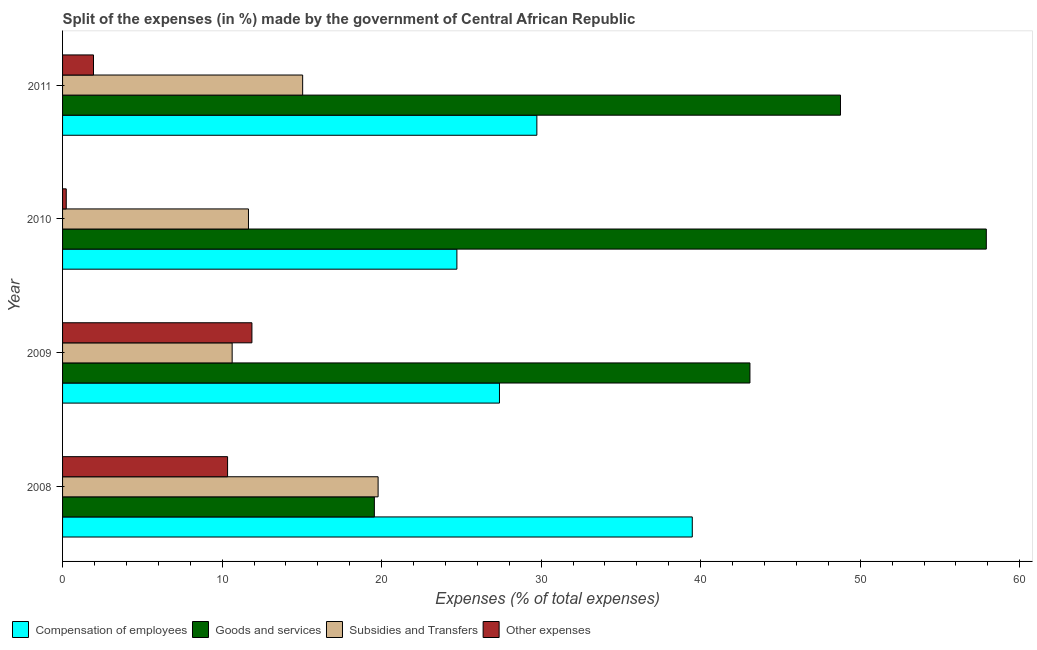How many different coloured bars are there?
Keep it short and to the point. 4. Are the number of bars per tick equal to the number of legend labels?
Your answer should be compact. Yes. How many bars are there on the 3rd tick from the bottom?
Your answer should be compact. 4. What is the label of the 4th group of bars from the top?
Provide a short and direct response. 2008. What is the percentage of amount spent on compensation of employees in 2009?
Provide a short and direct response. 27.39. Across all years, what is the maximum percentage of amount spent on other expenses?
Your answer should be very brief. 11.87. Across all years, what is the minimum percentage of amount spent on subsidies?
Offer a very short reply. 10.63. In which year was the percentage of amount spent on goods and services maximum?
Give a very brief answer. 2010. In which year was the percentage of amount spent on goods and services minimum?
Offer a very short reply. 2008. What is the total percentage of amount spent on goods and services in the graph?
Your answer should be compact. 169.3. What is the difference between the percentage of amount spent on compensation of employees in 2010 and that in 2011?
Offer a terse response. -5.01. What is the difference between the percentage of amount spent on subsidies in 2010 and the percentage of amount spent on compensation of employees in 2009?
Offer a terse response. -15.73. What is the average percentage of amount spent on subsidies per year?
Offer a very short reply. 14.28. In the year 2011, what is the difference between the percentage of amount spent on compensation of employees and percentage of amount spent on goods and services?
Ensure brevity in your answer.  -19.03. In how many years, is the percentage of amount spent on subsidies greater than 16 %?
Your answer should be compact. 1. What is the ratio of the percentage of amount spent on goods and services in 2008 to that in 2009?
Offer a terse response. 0.45. What is the difference between the highest and the second highest percentage of amount spent on other expenses?
Offer a very short reply. 1.53. What is the difference between the highest and the lowest percentage of amount spent on subsidies?
Keep it short and to the point. 9.15. Is it the case that in every year, the sum of the percentage of amount spent on goods and services and percentage of amount spent on other expenses is greater than the sum of percentage of amount spent on compensation of employees and percentage of amount spent on subsidies?
Provide a short and direct response. No. What does the 1st bar from the top in 2008 represents?
Ensure brevity in your answer.  Other expenses. What does the 1st bar from the bottom in 2008 represents?
Offer a very short reply. Compensation of employees. How many bars are there?
Your answer should be very brief. 16. Are all the bars in the graph horizontal?
Offer a terse response. Yes. How many years are there in the graph?
Your response must be concise. 4. What is the difference between two consecutive major ticks on the X-axis?
Offer a very short reply. 10. What is the title of the graph?
Offer a very short reply. Split of the expenses (in %) made by the government of Central African Republic. Does "Social Protection" appear as one of the legend labels in the graph?
Your response must be concise. No. What is the label or title of the X-axis?
Your response must be concise. Expenses (% of total expenses). What is the Expenses (% of total expenses) in Compensation of employees in 2008?
Your answer should be compact. 39.47. What is the Expenses (% of total expenses) of Goods and services in 2008?
Offer a very short reply. 19.55. What is the Expenses (% of total expenses) in Subsidies and Transfers in 2008?
Provide a short and direct response. 19.78. What is the Expenses (% of total expenses) of Other expenses in 2008?
Ensure brevity in your answer.  10.34. What is the Expenses (% of total expenses) in Compensation of employees in 2009?
Give a very brief answer. 27.39. What is the Expenses (% of total expenses) in Goods and services in 2009?
Your answer should be very brief. 43.09. What is the Expenses (% of total expenses) of Subsidies and Transfers in 2009?
Make the answer very short. 10.63. What is the Expenses (% of total expenses) in Other expenses in 2009?
Ensure brevity in your answer.  11.87. What is the Expenses (% of total expenses) in Compensation of employees in 2010?
Keep it short and to the point. 24.72. What is the Expenses (% of total expenses) in Goods and services in 2010?
Ensure brevity in your answer.  57.91. What is the Expenses (% of total expenses) in Subsidies and Transfers in 2010?
Make the answer very short. 11.65. What is the Expenses (% of total expenses) in Other expenses in 2010?
Keep it short and to the point. 0.23. What is the Expenses (% of total expenses) in Compensation of employees in 2011?
Your response must be concise. 29.73. What is the Expenses (% of total expenses) in Goods and services in 2011?
Your answer should be very brief. 48.76. What is the Expenses (% of total expenses) of Subsidies and Transfers in 2011?
Your response must be concise. 15.05. What is the Expenses (% of total expenses) of Other expenses in 2011?
Keep it short and to the point. 1.94. Across all years, what is the maximum Expenses (% of total expenses) in Compensation of employees?
Your answer should be very brief. 39.47. Across all years, what is the maximum Expenses (% of total expenses) of Goods and services?
Your answer should be very brief. 57.91. Across all years, what is the maximum Expenses (% of total expenses) in Subsidies and Transfers?
Provide a short and direct response. 19.78. Across all years, what is the maximum Expenses (% of total expenses) of Other expenses?
Provide a short and direct response. 11.87. Across all years, what is the minimum Expenses (% of total expenses) of Compensation of employees?
Provide a succinct answer. 24.72. Across all years, what is the minimum Expenses (% of total expenses) in Goods and services?
Keep it short and to the point. 19.55. Across all years, what is the minimum Expenses (% of total expenses) in Subsidies and Transfers?
Offer a very short reply. 10.63. Across all years, what is the minimum Expenses (% of total expenses) of Other expenses?
Ensure brevity in your answer.  0.23. What is the total Expenses (% of total expenses) in Compensation of employees in the graph?
Keep it short and to the point. 121.31. What is the total Expenses (% of total expenses) of Goods and services in the graph?
Provide a succinct answer. 169.3. What is the total Expenses (% of total expenses) in Subsidies and Transfers in the graph?
Keep it short and to the point. 57.11. What is the total Expenses (% of total expenses) of Other expenses in the graph?
Your response must be concise. 24.38. What is the difference between the Expenses (% of total expenses) in Compensation of employees in 2008 and that in 2009?
Make the answer very short. 12.09. What is the difference between the Expenses (% of total expenses) in Goods and services in 2008 and that in 2009?
Your answer should be very brief. -23.54. What is the difference between the Expenses (% of total expenses) in Subsidies and Transfers in 2008 and that in 2009?
Your answer should be compact. 9.15. What is the difference between the Expenses (% of total expenses) in Other expenses in 2008 and that in 2009?
Your response must be concise. -1.53. What is the difference between the Expenses (% of total expenses) of Compensation of employees in 2008 and that in 2010?
Offer a terse response. 14.76. What is the difference between the Expenses (% of total expenses) of Goods and services in 2008 and that in 2010?
Ensure brevity in your answer.  -38.36. What is the difference between the Expenses (% of total expenses) in Subsidies and Transfers in 2008 and that in 2010?
Offer a very short reply. 8.13. What is the difference between the Expenses (% of total expenses) of Other expenses in 2008 and that in 2010?
Provide a short and direct response. 10.11. What is the difference between the Expenses (% of total expenses) in Compensation of employees in 2008 and that in 2011?
Keep it short and to the point. 9.74. What is the difference between the Expenses (% of total expenses) of Goods and services in 2008 and that in 2011?
Your response must be concise. -29.22. What is the difference between the Expenses (% of total expenses) of Subsidies and Transfers in 2008 and that in 2011?
Keep it short and to the point. 4.73. What is the difference between the Expenses (% of total expenses) of Other expenses in 2008 and that in 2011?
Give a very brief answer. 8.4. What is the difference between the Expenses (% of total expenses) of Compensation of employees in 2009 and that in 2010?
Make the answer very short. 2.67. What is the difference between the Expenses (% of total expenses) in Goods and services in 2009 and that in 2010?
Provide a succinct answer. -14.82. What is the difference between the Expenses (% of total expenses) of Subsidies and Transfers in 2009 and that in 2010?
Make the answer very short. -1.02. What is the difference between the Expenses (% of total expenses) in Other expenses in 2009 and that in 2010?
Provide a succinct answer. 11.64. What is the difference between the Expenses (% of total expenses) of Compensation of employees in 2009 and that in 2011?
Your answer should be very brief. -2.34. What is the difference between the Expenses (% of total expenses) of Goods and services in 2009 and that in 2011?
Provide a succinct answer. -5.68. What is the difference between the Expenses (% of total expenses) of Subsidies and Transfers in 2009 and that in 2011?
Make the answer very short. -4.42. What is the difference between the Expenses (% of total expenses) in Other expenses in 2009 and that in 2011?
Your response must be concise. 9.93. What is the difference between the Expenses (% of total expenses) of Compensation of employees in 2010 and that in 2011?
Your answer should be very brief. -5.01. What is the difference between the Expenses (% of total expenses) of Goods and services in 2010 and that in 2011?
Provide a short and direct response. 9.14. What is the difference between the Expenses (% of total expenses) of Subsidies and Transfers in 2010 and that in 2011?
Offer a terse response. -3.4. What is the difference between the Expenses (% of total expenses) of Other expenses in 2010 and that in 2011?
Make the answer very short. -1.71. What is the difference between the Expenses (% of total expenses) in Compensation of employees in 2008 and the Expenses (% of total expenses) in Goods and services in 2009?
Give a very brief answer. -3.61. What is the difference between the Expenses (% of total expenses) of Compensation of employees in 2008 and the Expenses (% of total expenses) of Subsidies and Transfers in 2009?
Your answer should be very brief. 28.84. What is the difference between the Expenses (% of total expenses) in Compensation of employees in 2008 and the Expenses (% of total expenses) in Other expenses in 2009?
Provide a succinct answer. 27.6. What is the difference between the Expenses (% of total expenses) of Goods and services in 2008 and the Expenses (% of total expenses) of Subsidies and Transfers in 2009?
Give a very brief answer. 8.91. What is the difference between the Expenses (% of total expenses) in Goods and services in 2008 and the Expenses (% of total expenses) in Other expenses in 2009?
Provide a short and direct response. 7.68. What is the difference between the Expenses (% of total expenses) in Subsidies and Transfers in 2008 and the Expenses (% of total expenses) in Other expenses in 2009?
Provide a short and direct response. 7.91. What is the difference between the Expenses (% of total expenses) in Compensation of employees in 2008 and the Expenses (% of total expenses) in Goods and services in 2010?
Provide a short and direct response. -18.43. What is the difference between the Expenses (% of total expenses) in Compensation of employees in 2008 and the Expenses (% of total expenses) in Subsidies and Transfers in 2010?
Give a very brief answer. 27.82. What is the difference between the Expenses (% of total expenses) in Compensation of employees in 2008 and the Expenses (% of total expenses) in Other expenses in 2010?
Your answer should be very brief. 39.24. What is the difference between the Expenses (% of total expenses) in Goods and services in 2008 and the Expenses (% of total expenses) in Subsidies and Transfers in 2010?
Your answer should be very brief. 7.89. What is the difference between the Expenses (% of total expenses) of Goods and services in 2008 and the Expenses (% of total expenses) of Other expenses in 2010?
Give a very brief answer. 19.31. What is the difference between the Expenses (% of total expenses) of Subsidies and Transfers in 2008 and the Expenses (% of total expenses) of Other expenses in 2010?
Provide a succinct answer. 19.55. What is the difference between the Expenses (% of total expenses) in Compensation of employees in 2008 and the Expenses (% of total expenses) in Goods and services in 2011?
Give a very brief answer. -9.29. What is the difference between the Expenses (% of total expenses) in Compensation of employees in 2008 and the Expenses (% of total expenses) in Subsidies and Transfers in 2011?
Make the answer very short. 24.42. What is the difference between the Expenses (% of total expenses) in Compensation of employees in 2008 and the Expenses (% of total expenses) in Other expenses in 2011?
Your answer should be compact. 37.53. What is the difference between the Expenses (% of total expenses) of Goods and services in 2008 and the Expenses (% of total expenses) of Subsidies and Transfers in 2011?
Give a very brief answer. 4.5. What is the difference between the Expenses (% of total expenses) in Goods and services in 2008 and the Expenses (% of total expenses) in Other expenses in 2011?
Your response must be concise. 17.61. What is the difference between the Expenses (% of total expenses) in Subsidies and Transfers in 2008 and the Expenses (% of total expenses) in Other expenses in 2011?
Provide a short and direct response. 17.84. What is the difference between the Expenses (% of total expenses) in Compensation of employees in 2009 and the Expenses (% of total expenses) in Goods and services in 2010?
Give a very brief answer. -30.52. What is the difference between the Expenses (% of total expenses) of Compensation of employees in 2009 and the Expenses (% of total expenses) of Subsidies and Transfers in 2010?
Offer a terse response. 15.73. What is the difference between the Expenses (% of total expenses) of Compensation of employees in 2009 and the Expenses (% of total expenses) of Other expenses in 2010?
Provide a succinct answer. 27.16. What is the difference between the Expenses (% of total expenses) of Goods and services in 2009 and the Expenses (% of total expenses) of Subsidies and Transfers in 2010?
Keep it short and to the point. 31.44. What is the difference between the Expenses (% of total expenses) in Goods and services in 2009 and the Expenses (% of total expenses) in Other expenses in 2010?
Your response must be concise. 42.86. What is the difference between the Expenses (% of total expenses) of Subsidies and Transfers in 2009 and the Expenses (% of total expenses) of Other expenses in 2010?
Offer a very short reply. 10.4. What is the difference between the Expenses (% of total expenses) of Compensation of employees in 2009 and the Expenses (% of total expenses) of Goods and services in 2011?
Keep it short and to the point. -21.38. What is the difference between the Expenses (% of total expenses) of Compensation of employees in 2009 and the Expenses (% of total expenses) of Subsidies and Transfers in 2011?
Give a very brief answer. 12.34. What is the difference between the Expenses (% of total expenses) of Compensation of employees in 2009 and the Expenses (% of total expenses) of Other expenses in 2011?
Your response must be concise. 25.45. What is the difference between the Expenses (% of total expenses) in Goods and services in 2009 and the Expenses (% of total expenses) in Subsidies and Transfers in 2011?
Ensure brevity in your answer.  28.04. What is the difference between the Expenses (% of total expenses) in Goods and services in 2009 and the Expenses (% of total expenses) in Other expenses in 2011?
Your response must be concise. 41.15. What is the difference between the Expenses (% of total expenses) of Subsidies and Transfers in 2009 and the Expenses (% of total expenses) of Other expenses in 2011?
Make the answer very short. 8.69. What is the difference between the Expenses (% of total expenses) of Compensation of employees in 2010 and the Expenses (% of total expenses) of Goods and services in 2011?
Ensure brevity in your answer.  -24.05. What is the difference between the Expenses (% of total expenses) of Compensation of employees in 2010 and the Expenses (% of total expenses) of Subsidies and Transfers in 2011?
Keep it short and to the point. 9.67. What is the difference between the Expenses (% of total expenses) in Compensation of employees in 2010 and the Expenses (% of total expenses) in Other expenses in 2011?
Make the answer very short. 22.78. What is the difference between the Expenses (% of total expenses) in Goods and services in 2010 and the Expenses (% of total expenses) in Subsidies and Transfers in 2011?
Offer a terse response. 42.85. What is the difference between the Expenses (% of total expenses) of Goods and services in 2010 and the Expenses (% of total expenses) of Other expenses in 2011?
Your answer should be compact. 55.97. What is the difference between the Expenses (% of total expenses) of Subsidies and Transfers in 2010 and the Expenses (% of total expenses) of Other expenses in 2011?
Offer a terse response. 9.71. What is the average Expenses (% of total expenses) in Compensation of employees per year?
Offer a terse response. 30.33. What is the average Expenses (% of total expenses) of Goods and services per year?
Keep it short and to the point. 42.33. What is the average Expenses (% of total expenses) of Subsidies and Transfers per year?
Your answer should be compact. 14.28. What is the average Expenses (% of total expenses) of Other expenses per year?
Provide a short and direct response. 6.1. In the year 2008, what is the difference between the Expenses (% of total expenses) of Compensation of employees and Expenses (% of total expenses) of Goods and services?
Offer a very short reply. 19.93. In the year 2008, what is the difference between the Expenses (% of total expenses) in Compensation of employees and Expenses (% of total expenses) in Subsidies and Transfers?
Offer a very short reply. 19.69. In the year 2008, what is the difference between the Expenses (% of total expenses) of Compensation of employees and Expenses (% of total expenses) of Other expenses?
Give a very brief answer. 29.13. In the year 2008, what is the difference between the Expenses (% of total expenses) in Goods and services and Expenses (% of total expenses) in Subsidies and Transfers?
Offer a very short reply. -0.23. In the year 2008, what is the difference between the Expenses (% of total expenses) in Goods and services and Expenses (% of total expenses) in Other expenses?
Provide a short and direct response. 9.2. In the year 2008, what is the difference between the Expenses (% of total expenses) in Subsidies and Transfers and Expenses (% of total expenses) in Other expenses?
Your response must be concise. 9.44. In the year 2009, what is the difference between the Expenses (% of total expenses) of Compensation of employees and Expenses (% of total expenses) of Goods and services?
Make the answer very short. -15.7. In the year 2009, what is the difference between the Expenses (% of total expenses) in Compensation of employees and Expenses (% of total expenses) in Subsidies and Transfers?
Your answer should be very brief. 16.76. In the year 2009, what is the difference between the Expenses (% of total expenses) of Compensation of employees and Expenses (% of total expenses) of Other expenses?
Ensure brevity in your answer.  15.52. In the year 2009, what is the difference between the Expenses (% of total expenses) in Goods and services and Expenses (% of total expenses) in Subsidies and Transfers?
Offer a terse response. 32.46. In the year 2009, what is the difference between the Expenses (% of total expenses) in Goods and services and Expenses (% of total expenses) in Other expenses?
Offer a very short reply. 31.22. In the year 2009, what is the difference between the Expenses (% of total expenses) in Subsidies and Transfers and Expenses (% of total expenses) in Other expenses?
Make the answer very short. -1.24. In the year 2010, what is the difference between the Expenses (% of total expenses) in Compensation of employees and Expenses (% of total expenses) in Goods and services?
Your response must be concise. -33.19. In the year 2010, what is the difference between the Expenses (% of total expenses) of Compensation of employees and Expenses (% of total expenses) of Subsidies and Transfers?
Provide a succinct answer. 13.07. In the year 2010, what is the difference between the Expenses (% of total expenses) in Compensation of employees and Expenses (% of total expenses) in Other expenses?
Your response must be concise. 24.49. In the year 2010, what is the difference between the Expenses (% of total expenses) of Goods and services and Expenses (% of total expenses) of Subsidies and Transfers?
Make the answer very short. 46.25. In the year 2010, what is the difference between the Expenses (% of total expenses) of Goods and services and Expenses (% of total expenses) of Other expenses?
Offer a very short reply. 57.67. In the year 2010, what is the difference between the Expenses (% of total expenses) of Subsidies and Transfers and Expenses (% of total expenses) of Other expenses?
Ensure brevity in your answer.  11.42. In the year 2011, what is the difference between the Expenses (% of total expenses) of Compensation of employees and Expenses (% of total expenses) of Goods and services?
Offer a terse response. -19.03. In the year 2011, what is the difference between the Expenses (% of total expenses) of Compensation of employees and Expenses (% of total expenses) of Subsidies and Transfers?
Offer a very short reply. 14.68. In the year 2011, what is the difference between the Expenses (% of total expenses) in Compensation of employees and Expenses (% of total expenses) in Other expenses?
Provide a succinct answer. 27.79. In the year 2011, what is the difference between the Expenses (% of total expenses) of Goods and services and Expenses (% of total expenses) of Subsidies and Transfers?
Provide a short and direct response. 33.71. In the year 2011, what is the difference between the Expenses (% of total expenses) in Goods and services and Expenses (% of total expenses) in Other expenses?
Offer a very short reply. 46.83. In the year 2011, what is the difference between the Expenses (% of total expenses) of Subsidies and Transfers and Expenses (% of total expenses) of Other expenses?
Provide a short and direct response. 13.11. What is the ratio of the Expenses (% of total expenses) in Compensation of employees in 2008 to that in 2009?
Provide a short and direct response. 1.44. What is the ratio of the Expenses (% of total expenses) in Goods and services in 2008 to that in 2009?
Offer a very short reply. 0.45. What is the ratio of the Expenses (% of total expenses) in Subsidies and Transfers in 2008 to that in 2009?
Keep it short and to the point. 1.86. What is the ratio of the Expenses (% of total expenses) of Other expenses in 2008 to that in 2009?
Provide a short and direct response. 0.87. What is the ratio of the Expenses (% of total expenses) of Compensation of employees in 2008 to that in 2010?
Make the answer very short. 1.6. What is the ratio of the Expenses (% of total expenses) in Goods and services in 2008 to that in 2010?
Give a very brief answer. 0.34. What is the ratio of the Expenses (% of total expenses) in Subsidies and Transfers in 2008 to that in 2010?
Give a very brief answer. 1.7. What is the ratio of the Expenses (% of total expenses) of Other expenses in 2008 to that in 2010?
Provide a short and direct response. 44.79. What is the ratio of the Expenses (% of total expenses) in Compensation of employees in 2008 to that in 2011?
Provide a short and direct response. 1.33. What is the ratio of the Expenses (% of total expenses) of Goods and services in 2008 to that in 2011?
Offer a terse response. 0.4. What is the ratio of the Expenses (% of total expenses) in Subsidies and Transfers in 2008 to that in 2011?
Ensure brevity in your answer.  1.31. What is the ratio of the Expenses (% of total expenses) of Other expenses in 2008 to that in 2011?
Offer a terse response. 5.33. What is the ratio of the Expenses (% of total expenses) in Compensation of employees in 2009 to that in 2010?
Your response must be concise. 1.11. What is the ratio of the Expenses (% of total expenses) in Goods and services in 2009 to that in 2010?
Ensure brevity in your answer.  0.74. What is the ratio of the Expenses (% of total expenses) of Subsidies and Transfers in 2009 to that in 2010?
Give a very brief answer. 0.91. What is the ratio of the Expenses (% of total expenses) of Other expenses in 2009 to that in 2010?
Keep it short and to the point. 51.4. What is the ratio of the Expenses (% of total expenses) of Compensation of employees in 2009 to that in 2011?
Your response must be concise. 0.92. What is the ratio of the Expenses (% of total expenses) in Goods and services in 2009 to that in 2011?
Give a very brief answer. 0.88. What is the ratio of the Expenses (% of total expenses) of Subsidies and Transfers in 2009 to that in 2011?
Provide a short and direct response. 0.71. What is the ratio of the Expenses (% of total expenses) of Other expenses in 2009 to that in 2011?
Ensure brevity in your answer.  6.12. What is the ratio of the Expenses (% of total expenses) of Compensation of employees in 2010 to that in 2011?
Provide a succinct answer. 0.83. What is the ratio of the Expenses (% of total expenses) in Goods and services in 2010 to that in 2011?
Give a very brief answer. 1.19. What is the ratio of the Expenses (% of total expenses) in Subsidies and Transfers in 2010 to that in 2011?
Offer a terse response. 0.77. What is the ratio of the Expenses (% of total expenses) in Other expenses in 2010 to that in 2011?
Provide a short and direct response. 0.12. What is the difference between the highest and the second highest Expenses (% of total expenses) in Compensation of employees?
Your answer should be very brief. 9.74. What is the difference between the highest and the second highest Expenses (% of total expenses) of Goods and services?
Your answer should be very brief. 9.14. What is the difference between the highest and the second highest Expenses (% of total expenses) in Subsidies and Transfers?
Offer a terse response. 4.73. What is the difference between the highest and the second highest Expenses (% of total expenses) of Other expenses?
Provide a short and direct response. 1.53. What is the difference between the highest and the lowest Expenses (% of total expenses) in Compensation of employees?
Provide a short and direct response. 14.76. What is the difference between the highest and the lowest Expenses (% of total expenses) of Goods and services?
Your answer should be compact. 38.36. What is the difference between the highest and the lowest Expenses (% of total expenses) of Subsidies and Transfers?
Give a very brief answer. 9.15. What is the difference between the highest and the lowest Expenses (% of total expenses) of Other expenses?
Ensure brevity in your answer.  11.64. 